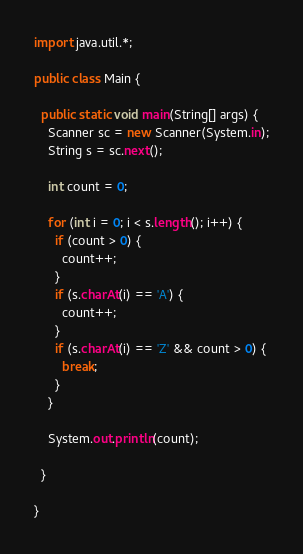Convert code to text. <code><loc_0><loc_0><loc_500><loc_500><_Java_>import java.util.*;

public class Main {

  public static void main(String[] args) {
    Scanner sc = new Scanner(System.in);
    String s = sc.next();

    int count = 0;

    for (int i = 0; i < s.length(); i++) {
      if (count > 0) {
        count++;
      }
      if (s.charAt(i) == 'A') {
        count++;
      }
      if (s.charAt(i) == 'Z' && count > 0) {
        break;
      }
    }

    System.out.println(count);

  }

}
</code> 